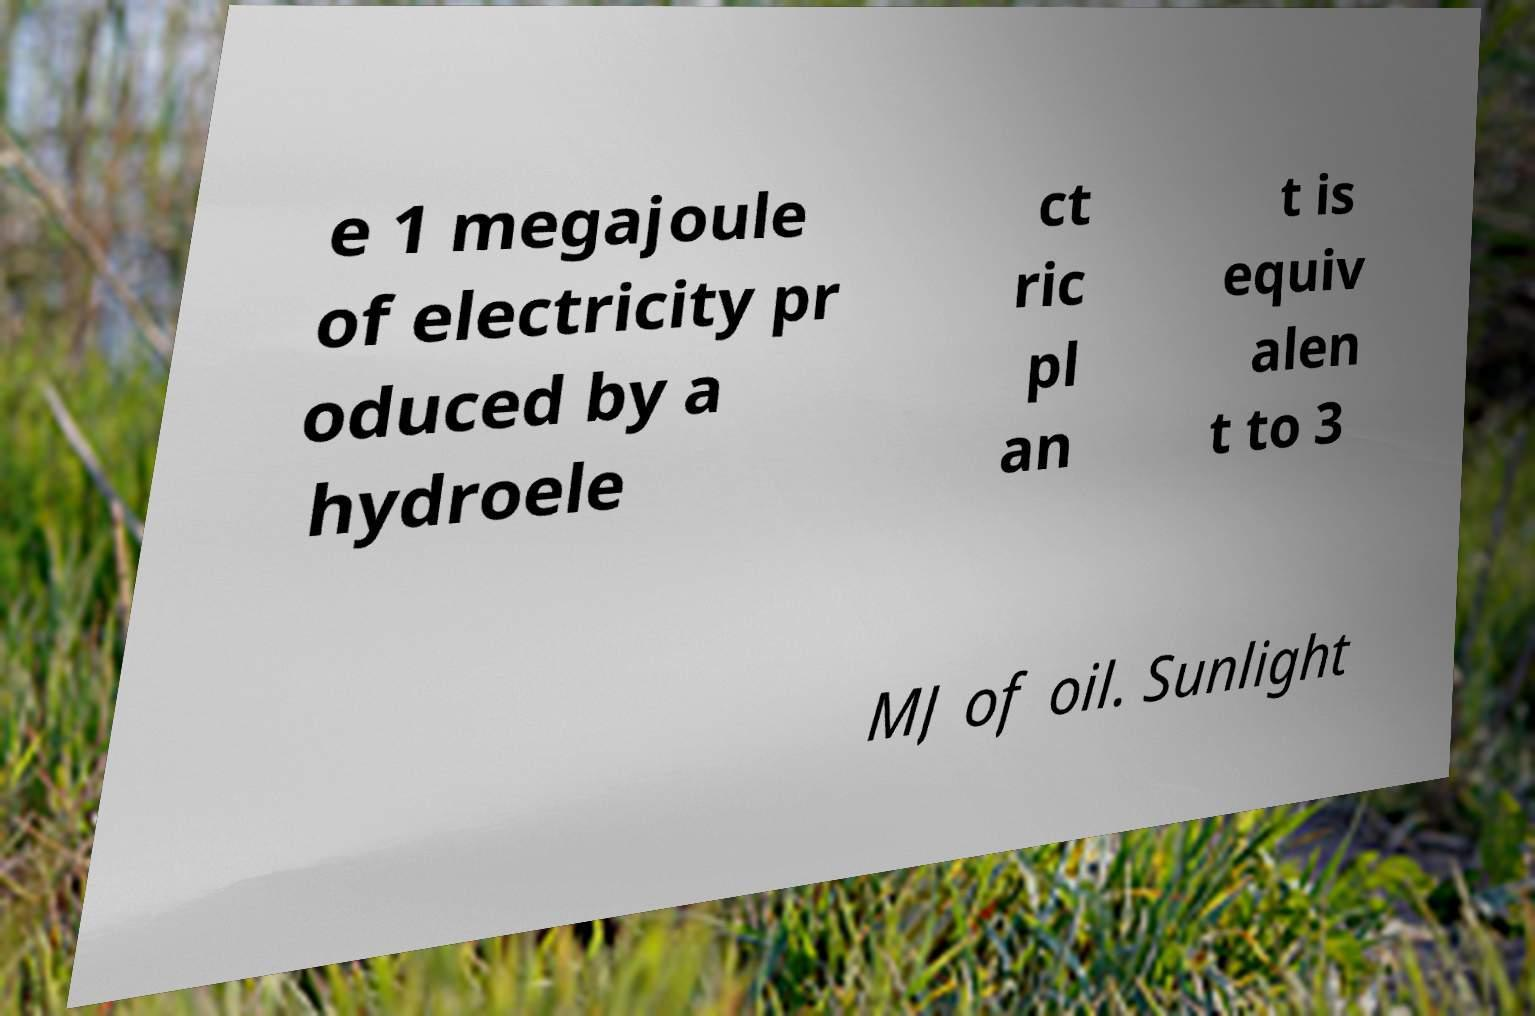What messages or text are displayed in this image? I need them in a readable, typed format. e 1 megajoule of electricity pr oduced by a hydroele ct ric pl an t is equiv alen t to 3 MJ of oil. Sunlight 